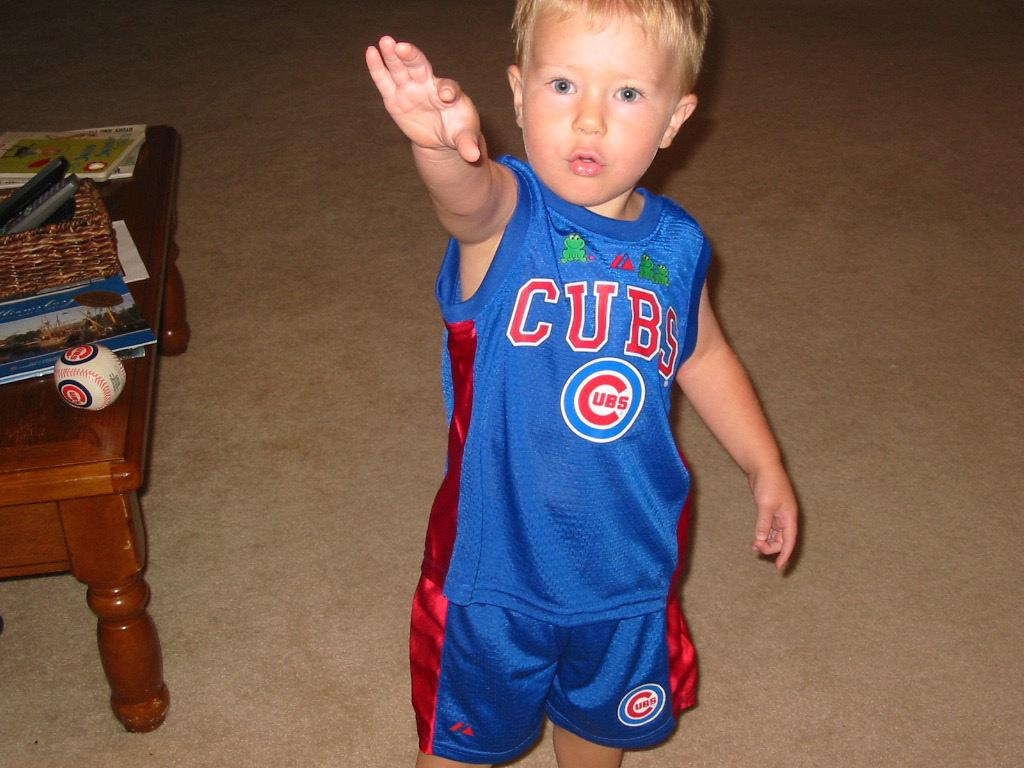<image>
Give a short and clear explanation of the subsequent image. A little boy wears a shirt with a Cubs logo. 